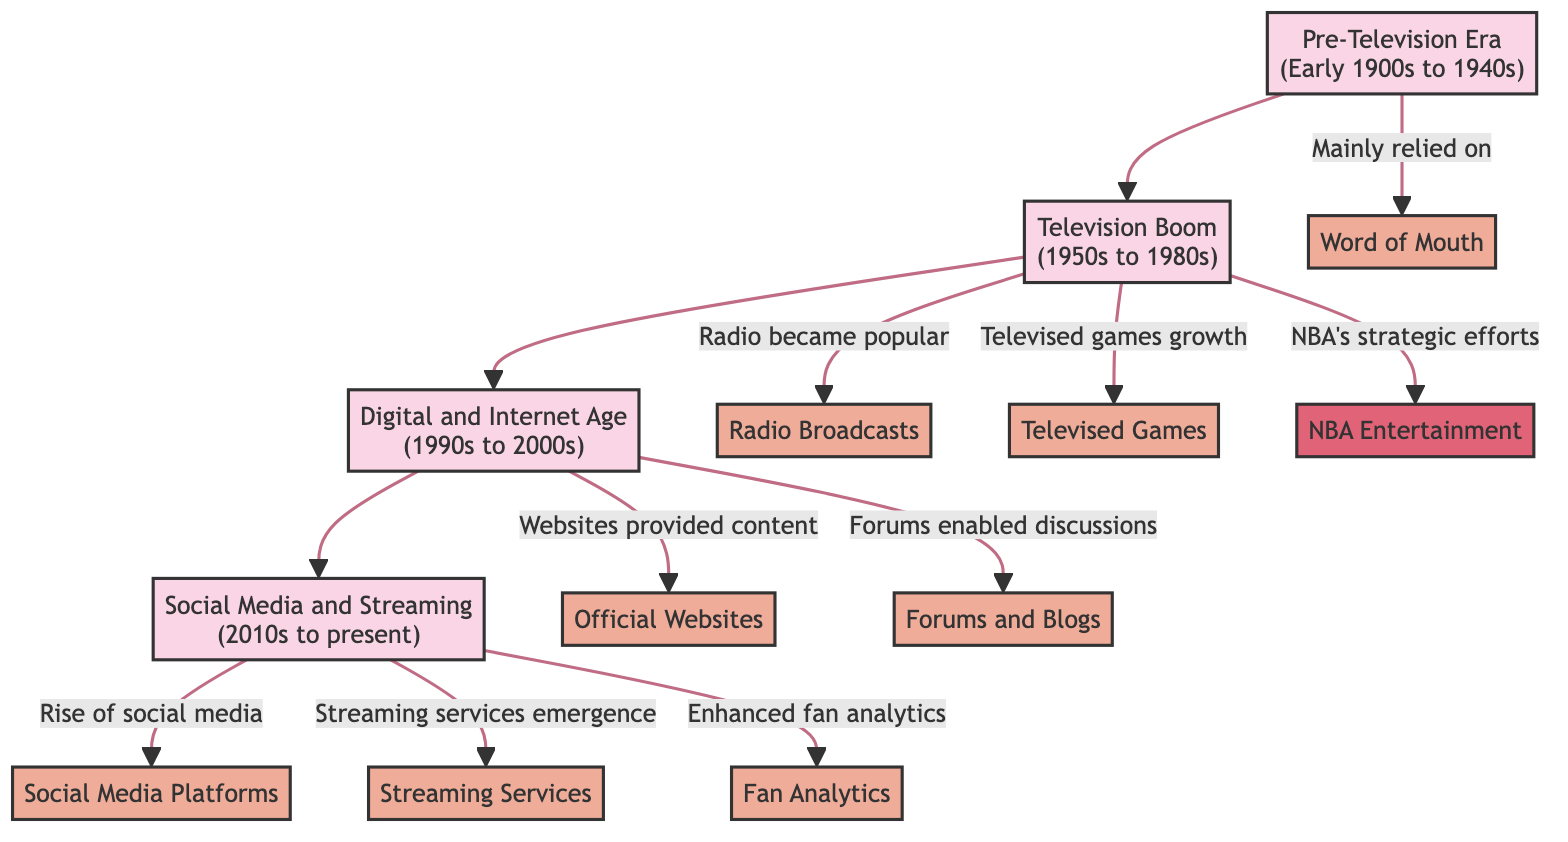What are the main engagement methods in the Pre-Television Era? The diagram shows that during the Pre-Television Era, the primary engagement method was "Word of Mouth." This can be seen by looking at the arrows leading from the Pre-Television Era node to the engagement method node labeled "Word of Mouth."
Answer: Word of Mouth Which era introduced television as a key engagement method? The diagram indicates that the Television Boom era (1950s to 1980s) saw the introduction of "Televised Games" as a key engagement method. This can be confirmed by following the arrows from the Television Boom era node to the "Televised Games" engagement method node.
Answer: Television Boom How many distinct time periods are represented in the diagram? The diagram visually represents four distinct time periods. By counting the nodes labeled with time periods, we find "Pre-Television Era," "Television Boom," "Digital and Internet Age," and "Social Media and Streaming," which totals four.
Answer: 4 What two engagement methods emerged in the Digital and Internet Age? The diagram indicates that during the Digital and Internet Age, two engagement methods emerged: "Official Websites" and "Forums and Blogs." This can be discerned from the arrows leading from the Digital and Internet Age node to these two engagement methods.
Answer: Official Websites and Forums and Blogs What advancement in fan engagement became prominent in the Social Media and Streaming era? In the Social Media and Streaming era, the emergence of "Social Media Platforms" is highlighted as a significant advancement in fan engagement. The diagram links this method directly from the Social Media and Streaming era node.
Answer: Social Media Platforms What organization was linked with the increase in televised games during the Television Boom? The diagram connects the "NBA Entertainment" organization with the growth of "Televised Games" during the Television Boom era. The connection can be traced through the arrows that relate the Television Boom with NBA Entertainment and Televised Games.
Answer: NBA Entertainment Which engagement method is associated with the rise of social media? The method associated with the rise of social media is "Social Media Platforms." This is indicated by the arrow leading to the engagement method node from the Social Media and Streaming era node, which signifies this relationship.
Answer: Social Media Platforms What is the primary communication method in basketball fan engagement prior to television? According to the diagram, the primary communication method before the television era was "Word of Mouth." This can be seen as the sole engagement method linked to the Pre-Television Era node.
Answer: Word of Mouth 